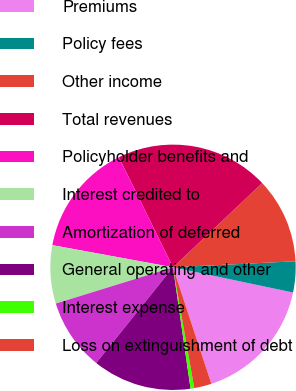Convert chart. <chart><loc_0><loc_0><loc_500><loc_500><pie_chart><fcel>Premiums<fcel>Policy fees<fcel>Other income<fcel>Total revenues<fcel>Policyholder benefits and<fcel>Interest credited to<fcel>Amortization of deferred<fcel>General operating and other<fcel>Interest expense<fcel>Loss on extinguishment of debt<nl><fcel>16.64%<fcel>4.08%<fcel>11.26%<fcel>20.23%<fcel>14.84%<fcel>7.67%<fcel>9.46%<fcel>13.05%<fcel>0.49%<fcel>2.29%<nl></chart> 